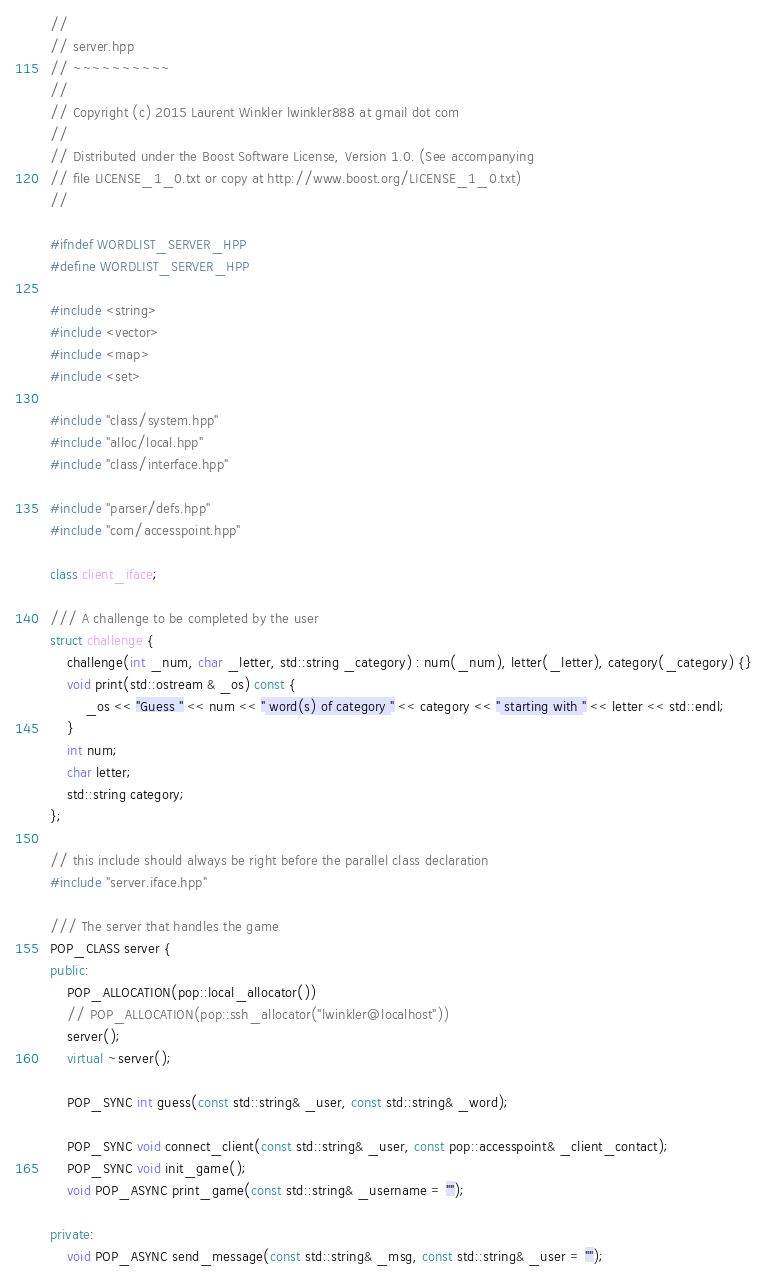<code> <loc_0><loc_0><loc_500><loc_500><_C++_>//
// server.hpp
// ~~~~~~~~~~
//
// Copyright (c) 2015 Laurent Winkler lwinkler888 at gmail dot com
//
// Distributed under the Boost Software License, Version 1.0. (See accompanying
// file LICENSE_1_0.txt or copy at http://www.boost.org/LICENSE_1_0.txt)
//

#ifndef WORDLIST_SERVER_HPP
#define WORDLIST_SERVER_HPP

#include <string>
#include <vector>
#include <map>
#include <set>

#include "class/system.hpp"
#include "alloc/local.hpp"
#include "class/interface.hpp"

#include "parser/defs.hpp"
#include "com/accesspoint.hpp"

class client_iface;

/// A challenge to be completed by the user
struct challenge {
	challenge(int _num, char _letter, std::string _category) : num(_num), letter(_letter), category(_category) {}
	void print(std::ostream & _os) const {
		_os << "Guess " << num << " word(s) of category " << category << " starting with " << letter << std::endl;
	}
	int num;
	char letter;
	std::string category;
};

// this include should always be right before the parallel class declaration
#include "server.iface.hpp"

/// The server that handles the game
POP_CLASS server {
public:
	POP_ALLOCATION(pop::local_allocator())
	// POP_ALLOCATION(pop::ssh_allocator("lwinkler@localhost"))
	server();
	virtual ~server();

	POP_SYNC int guess(const std::string& _user, const std::string& _word);

	POP_SYNC void connect_client(const std::string& _user, const pop::accesspoint& _client_contact);
	POP_SYNC void init_game();
	void POP_ASYNC print_game(const std::string& _username = "");

private:
	void POP_ASYNC send_message(const std::string& _msg, const std::string& _user = "");</code> 